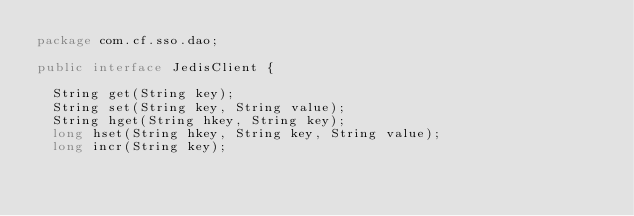<code> <loc_0><loc_0><loc_500><loc_500><_Java_>package com.cf.sso.dao;

public interface JedisClient {

	String get(String key);
	String set(String key, String value);
	String hget(String hkey, String key);
	long hset(String hkey, String key, String value);
	long incr(String key);</code> 